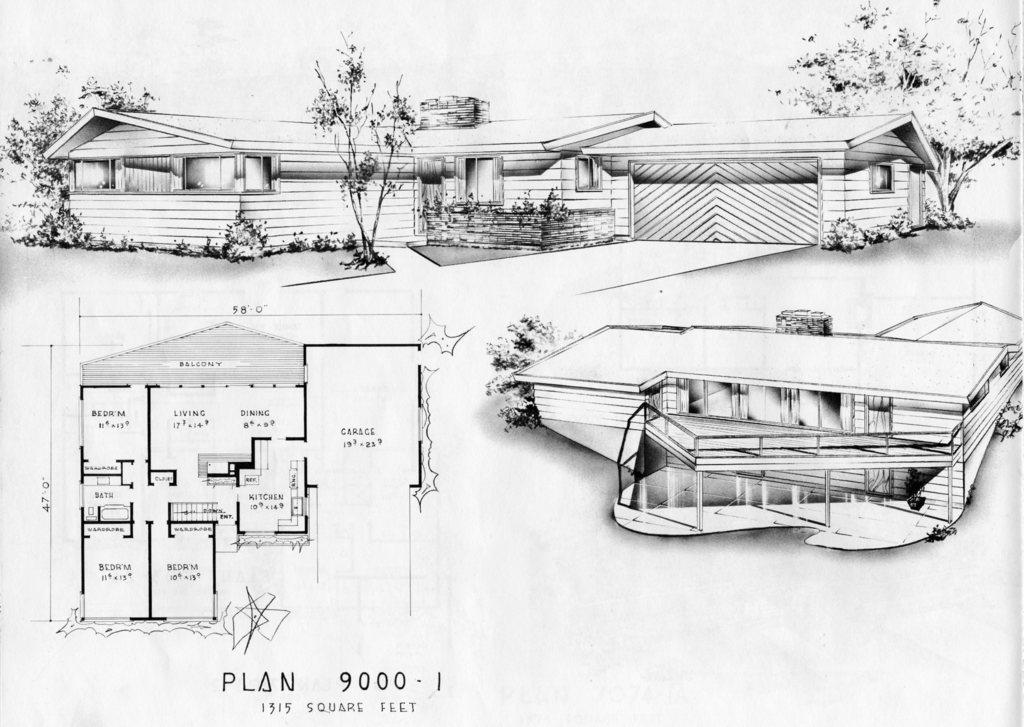What type of structures are present in the image? The image contains houses. What type of natural elements are present in the image? The image contains trees. What additional item can be seen in the image? There is a map in the image. What type of crib is visible in the image? There is no crib present in the image. What kind of thrill can be experienced by looking at the houses in the image? The image does not convey any specific emotions or experiences, so it is not possible to determine what kind of thrill might be associated with looking at the houses. 